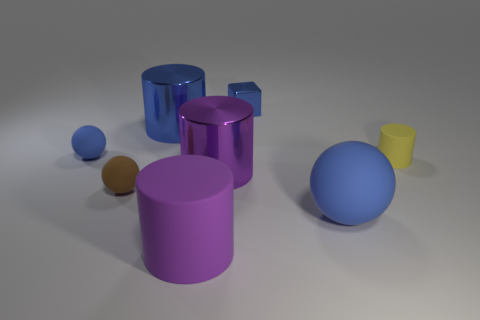How many other things are there of the same color as the tiny cylinder? There are no other objects in the image of the same exact color as the tiny cylinder. However, it's worth noting that there are other objects with similar hues but different shades, indicating a variety of colors within the same spectrum are depicted. 